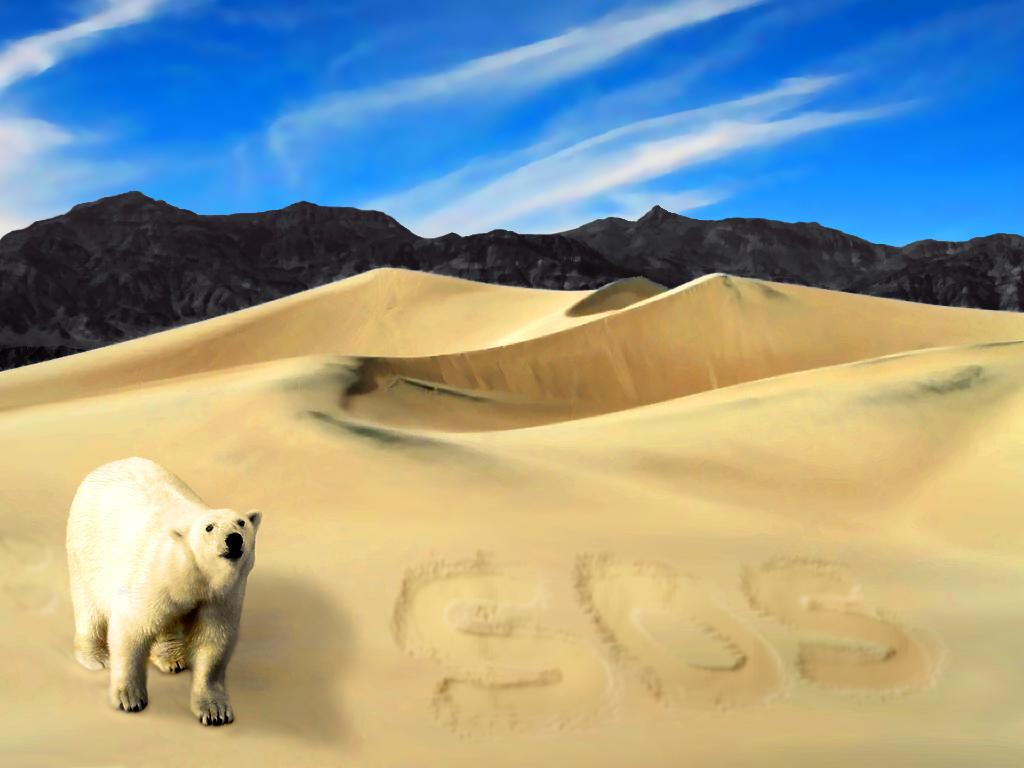What type of animal is in the image? There is a white polar bear in the image. Where is the polar bear located? The polar bear is standing in the desert. What can be seen in the background of the image? There are black heels and the sky visible in the background of the image. What is the condition of the sky in the image? Clouds are present in the sky. What type of account does the polar bear have on social media? There is no information about the polar bear's social media presence in the image. What level of education does the polar bear have? The image does not provide any information about the polar bear's education. 